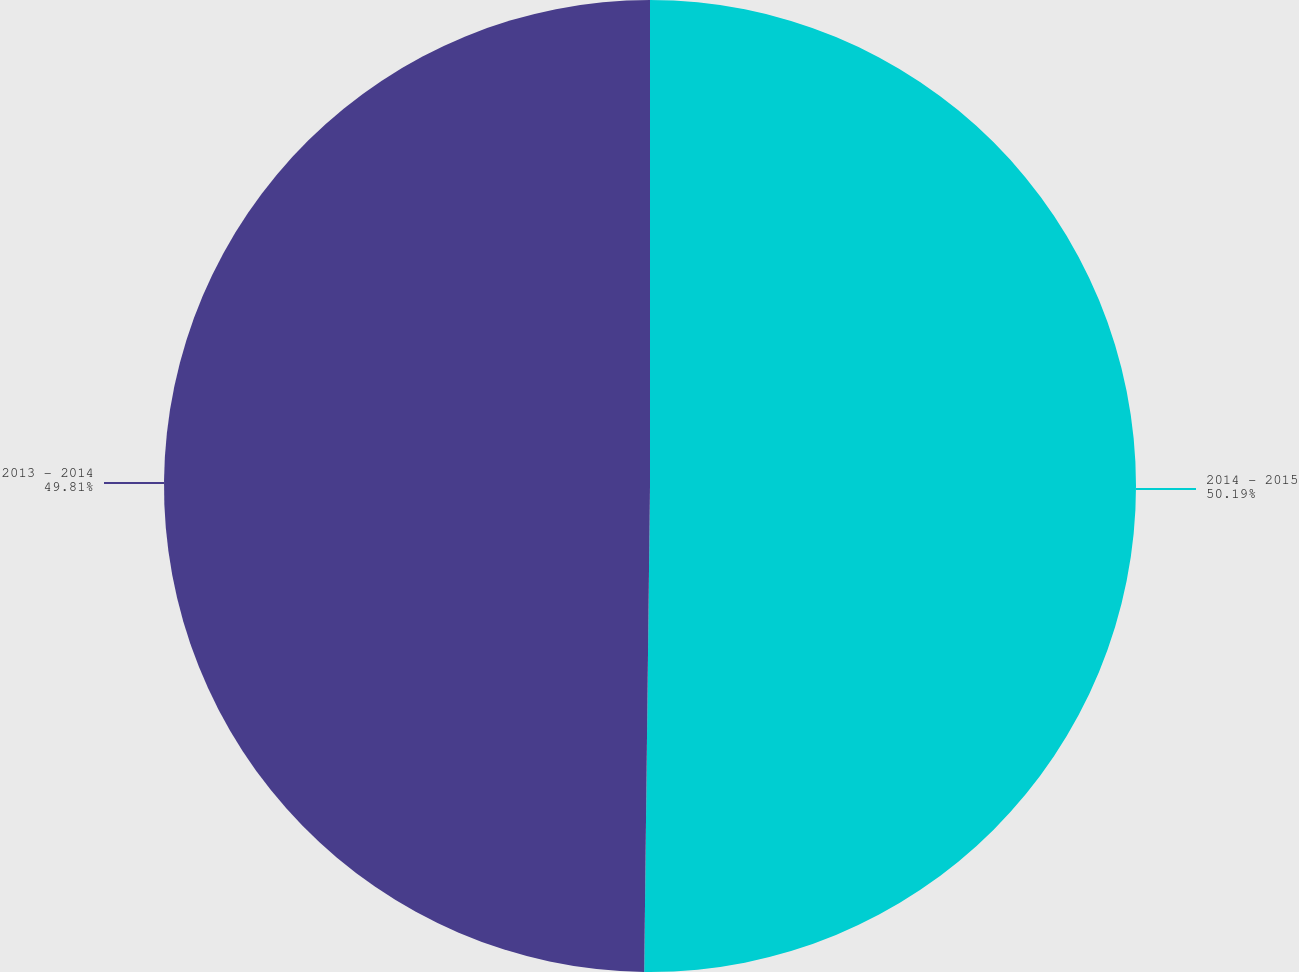Convert chart to OTSL. <chart><loc_0><loc_0><loc_500><loc_500><pie_chart><fcel>2014 - 2015<fcel>2013 - 2014<nl><fcel>50.19%<fcel>49.81%<nl></chart> 